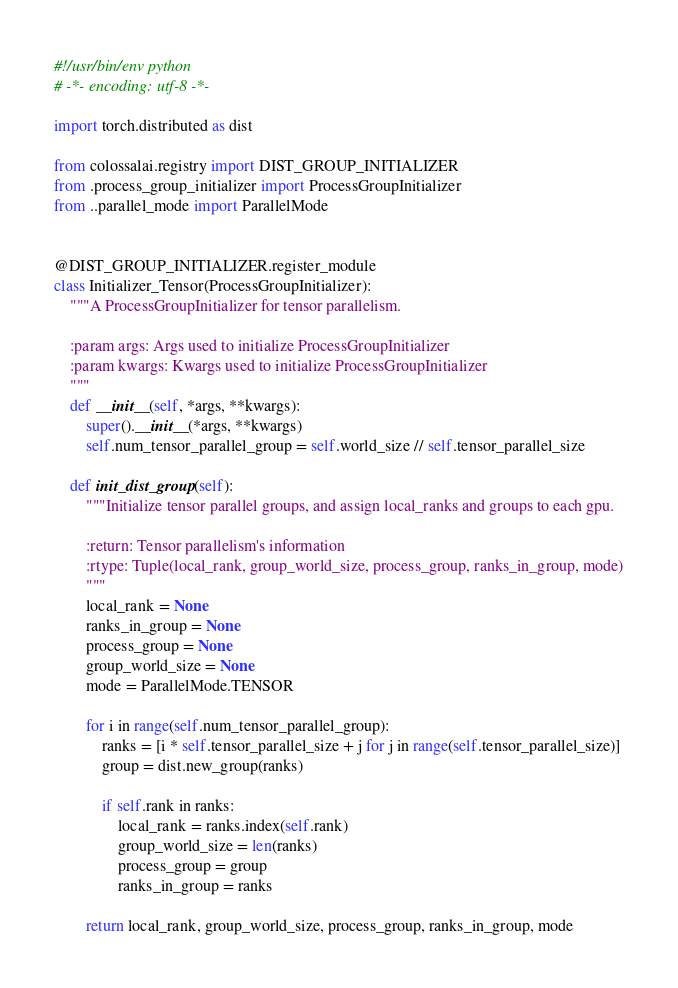Convert code to text. <code><loc_0><loc_0><loc_500><loc_500><_Python_>#!/usr/bin/env python
# -*- encoding: utf-8 -*-

import torch.distributed as dist

from colossalai.registry import DIST_GROUP_INITIALIZER
from .process_group_initializer import ProcessGroupInitializer
from ..parallel_mode import ParallelMode


@DIST_GROUP_INITIALIZER.register_module
class Initializer_Tensor(ProcessGroupInitializer):
    """A ProcessGroupInitializer for tensor parallelism.

    :param args: Args used to initialize ProcessGroupInitializer
    :param kwargs: Kwargs used to initialize ProcessGroupInitializer
    """
    def __init__(self, *args, **kwargs):
        super().__init__(*args, **kwargs)
        self.num_tensor_parallel_group = self.world_size // self.tensor_parallel_size

    def init_dist_group(self):
        """Initialize tensor parallel groups, and assign local_ranks and groups to each gpu.

        :return: Tensor parallelism's information
        :rtype: Tuple(local_rank, group_world_size, process_group, ranks_in_group, mode)
        """
        local_rank = None
        ranks_in_group = None
        process_group = None
        group_world_size = None
        mode = ParallelMode.TENSOR

        for i in range(self.num_tensor_parallel_group):
            ranks = [i * self.tensor_parallel_size + j for j in range(self.tensor_parallel_size)]
            group = dist.new_group(ranks)

            if self.rank in ranks:
                local_rank = ranks.index(self.rank)
                group_world_size = len(ranks)
                process_group = group
                ranks_in_group = ranks

        return local_rank, group_world_size, process_group, ranks_in_group, mode
</code> 